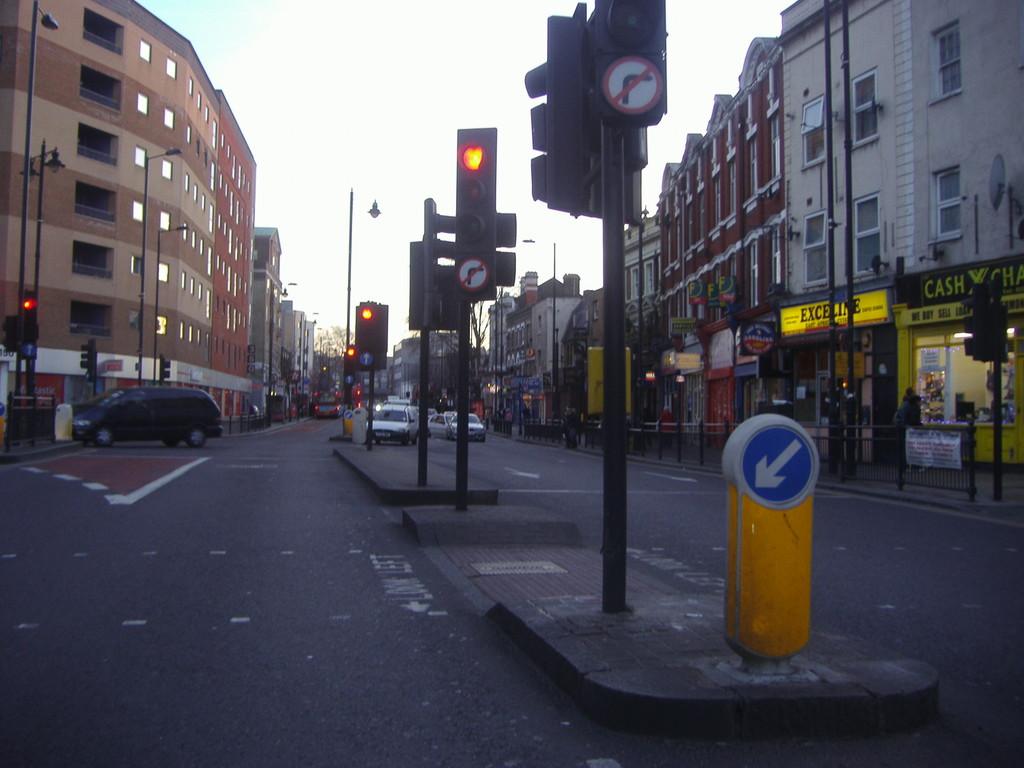What is the first four letter word can be clearly read on the shop front on the far right?
Your answer should be very brief. Cash. What is the first big word on that yellow banner?
Provide a succinct answer. Cash. 